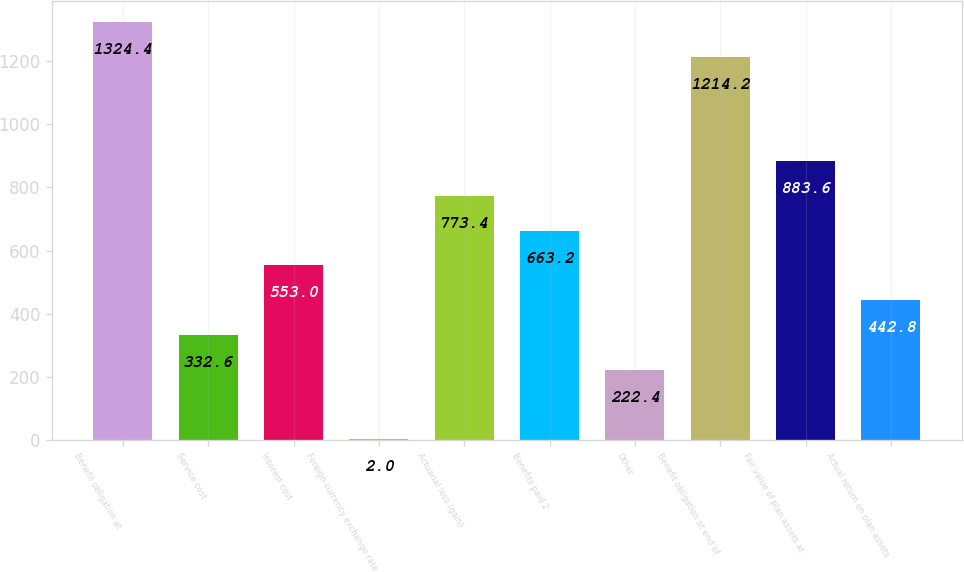Convert chart. <chart><loc_0><loc_0><loc_500><loc_500><bar_chart><fcel>Benefit obligation at<fcel>Service cost<fcel>Interest cost<fcel>Foreign currency exchange rate<fcel>Actuarial loss (gain)<fcel>Benefits paid 2<fcel>Other<fcel>Benefit obligation at end of<fcel>Fair value of plan assets at<fcel>Actual return on plan assets<nl><fcel>1324.4<fcel>332.6<fcel>553<fcel>2<fcel>773.4<fcel>663.2<fcel>222.4<fcel>1214.2<fcel>883.6<fcel>442.8<nl></chart> 